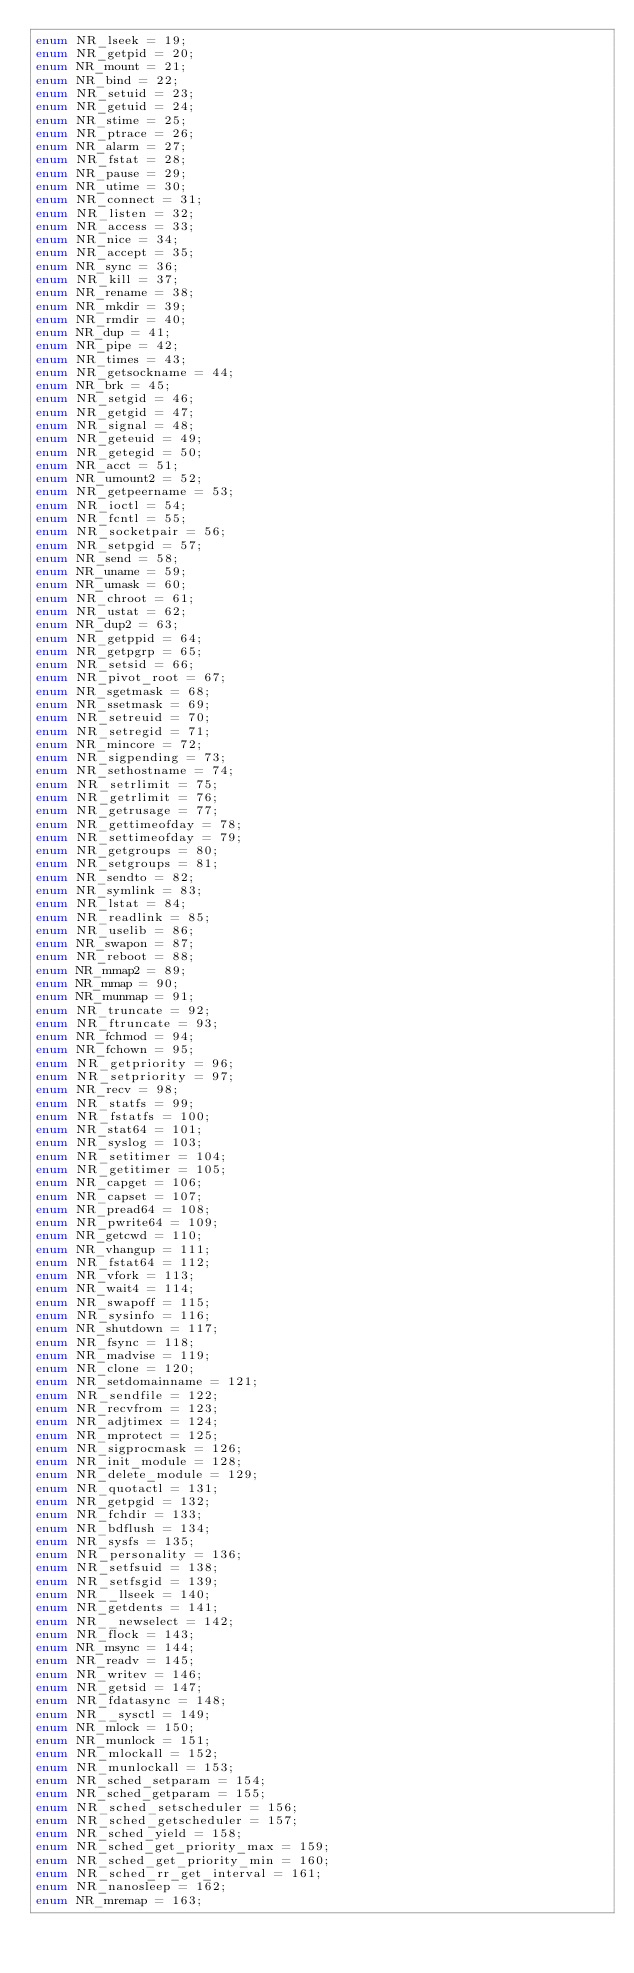<code> <loc_0><loc_0><loc_500><loc_500><_D_>enum NR_lseek = 19;
enum NR_getpid = 20;
enum NR_mount = 21;
enum NR_bind = 22;
enum NR_setuid = 23;
enum NR_getuid = 24;
enum NR_stime = 25;
enum NR_ptrace = 26;
enum NR_alarm = 27;
enum NR_fstat = 28;
enum NR_pause = 29;
enum NR_utime = 30;
enum NR_connect = 31;
enum NR_listen = 32;
enum NR_access = 33;
enum NR_nice = 34;
enum NR_accept = 35;
enum NR_sync = 36;
enum NR_kill = 37;
enum NR_rename = 38;
enum NR_mkdir = 39;
enum NR_rmdir = 40;
enum NR_dup = 41;
enum NR_pipe = 42;
enum NR_times = 43;
enum NR_getsockname = 44;
enum NR_brk = 45;
enum NR_setgid = 46;
enum NR_getgid = 47;
enum NR_signal = 48;
enum NR_geteuid = 49;
enum NR_getegid = 50;
enum NR_acct = 51;
enum NR_umount2 = 52;
enum NR_getpeername = 53;
enum NR_ioctl = 54;
enum NR_fcntl = 55;
enum NR_socketpair = 56;
enum NR_setpgid = 57;
enum NR_send = 58;
enum NR_uname = 59;
enum NR_umask = 60;
enum NR_chroot = 61;
enum NR_ustat = 62;
enum NR_dup2 = 63;
enum NR_getppid = 64;
enum NR_getpgrp = 65;
enum NR_setsid = 66;
enum NR_pivot_root = 67;
enum NR_sgetmask = 68;
enum NR_ssetmask = 69;
enum NR_setreuid = 70;
enum NR_setregid = 71;
enum NR_mincore = 72;
enum NR_sigpending = 73;
enum NR_sethostname = 74;
enum NR_setrlimit = 75;
enum NR_getrlimit = 76;
enum NR_getrusage = 77;
enum NR_gettimeofday = 78;
enum NR_settimeofday = 79;
enum NR_getgroups = 80;
enum NR_setgroups = 81;
enum NR_sendto = 82;
enum NR_symlink = 83;
enum NR_lstat = 84;
enum NR_readlink = 85;
enum NR_uselib = 86;
enum NR_swapon = 87;
enum NR_reboot = 88;
enum NR_mmap2 = 89;
enum NR_mmap = 90;
enum NR_munmap = 91;
enum NR_truncate = 92;
enum NR_ftruncate = 93;
enum NR_fchmod = 94;
enum NR_fchown = 95;
enum NR_getpriority = 96;
enum NR_setpriority = 97;
enum NR_recv = 98;
enum NR_statfs = 99;
enum NR_fstatfs = 100;
enum NR_stat64 = 101;
enum NR_syslog = 103;
enum NR_setitimer = 104;
enum NR_getitimer = 105;
enum NR_capget = 106;
enum NR_capset = 107;
enum NR_pread64 = 108;
enum NR_pwrite64 = 109;
enum NR_getcwd = 110;
enum NR_vhangup = 111;
enum NR_fstat64 = 112;
enum NR_vfork = 113;
enum NR_wait4 = 114;
enum NR_swapoff = 115;
enum NR_sysinfo = 116;
enum NR_shutdown = 117;
enum NR_fsync = 118;
enum NR_madvise = 119;
enum NR_clone = 120;
enum NR_setdomainname = 121;
enum NR_sendfile = 122;
enum NR_recvfrom = 123;
enum NR_adjtimex = 124;
enum NR_mprotect = 125;
enum NR_sigprocmask = 126;
enum NR_init_module = 128;
enum NR_delete_module = 129;
enum NR_quotactl = 131;
enum NR_getpgid = 132;
enum NR_fchdir = 133;
enum NR_bdflush = 134;
enum NR_sysfs = 135;
enum NR_personality = 136;
enum NR_setfsuid = 138;
enum NR_setfsgid = 139;
enum NR__llseek = 140;
enum NR_getdents = 141;
enum NR__newselect = 142;
enum NR_flock = 143;
enum NR_msync = 144;
enum NR_readv = 145;
enum NR_writev = 146;
enum NR_getsid = 147;
enum NR_fdatasync = 148;
enum NR__sysctl = 149;
enum NR_mlock = 150;
enum NR_munlock = 151;
enum NR_mlockall = 152;
enum NR_munlockall = 153;
enum NR_sched_setparam = 154;
enum NR_sched_getparam = 155;
enum NR_sched_setscheduler = 156;
enum NR_sched_getscheduler = 157;
enum NR_sched_yield = 158;
enum NR_sched_get_priority_max = 159;
enum NR_sched_get_priority_min = 160;
enum NR_sched_rr_get_interval = 161;
enum NR_nanosleep = 162;
enum NR_mremap = 163;</code> 